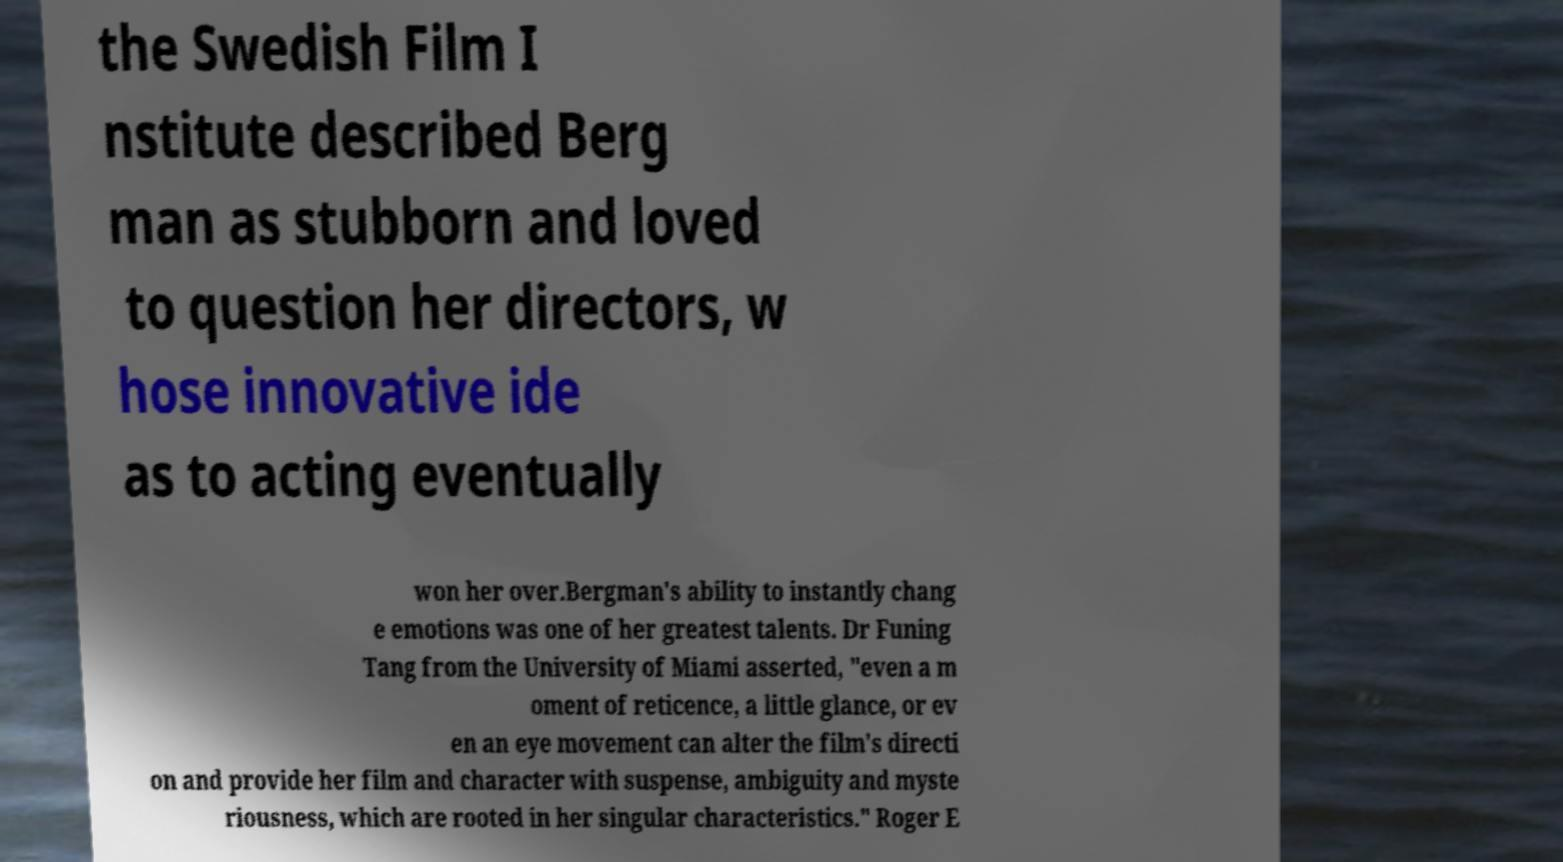There's text embedded in this image that I need extracted. Can you transcribe it verbatim? the Swedish Film I nstitute described Berg man as stubborn and loved to question her directors, w hose innovative ide as to acting eventually won her over.Bergman's ability to instantly chang e emotions was one of her greatest talents. Dr Funing Tang from the University of Miami asserted, "even a m oment of reticence, a little glance, or ev en an eye movement can alter the film's directi on and provide her film and character with suspense, ambiguity and myste riousness, which are rooted in her singular characteristics." Roger E 